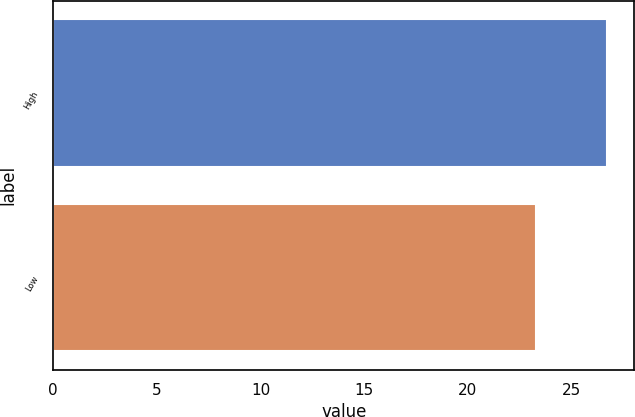Convert chart to OTSL. <chart><loc_0><loc_0><loc_500><loc_500><bar_chart><fcel>High<fcel>Low<nl><fcel>26.69<fcel>23.28<nl></chart> 